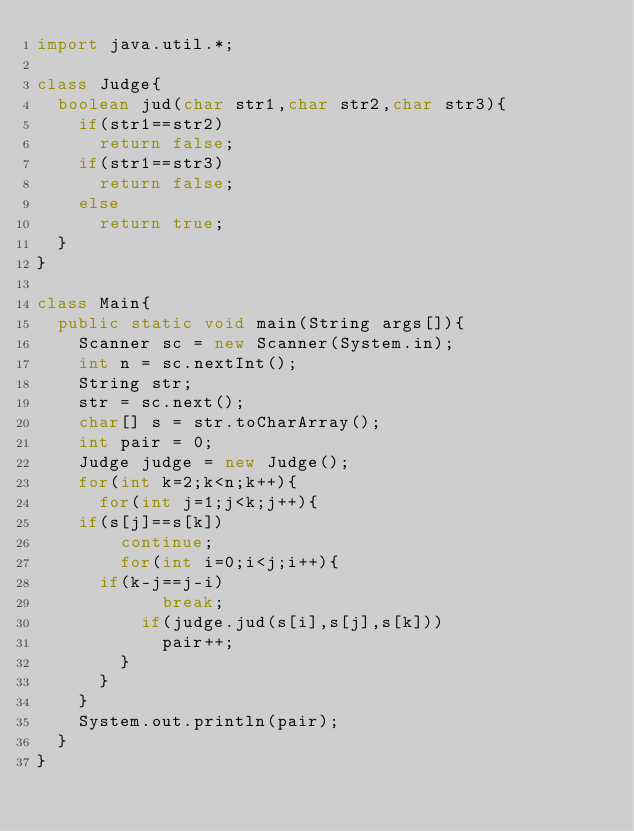Convert code to text. <code><loc_0><loc_0><loc_500><loc_500><_Java_>import java.util.*;

class Judge{
  boolean jud(char str1,char str2,char str3){
    if(str1==str2)
      return false;
    if(str1==str3)
      return false;
    else
      return true;
  }
}

class Main{
  public static void main(String args[]){
    Scanner sc = new Scanner(System.in);
    int n = sc.nextInt();
    String str;
    str = sc.next();
    char[] s = str.toCharArray();
    int pair = 0;
    Judge judge = new Judge();
    for(int k=2;k<n;k++){
      for(int j=1;j<k;j++){
	if(s[j]==s[k])
	    continue;
        for(int i=0;i<j;i++){
	  if(k-j==j-i)
            break;
          if(judge.jud(s[i],s[j],s[k]))
            pair++;
        }
      }
    }
    System.out.println(pair);
  }
}</code> 